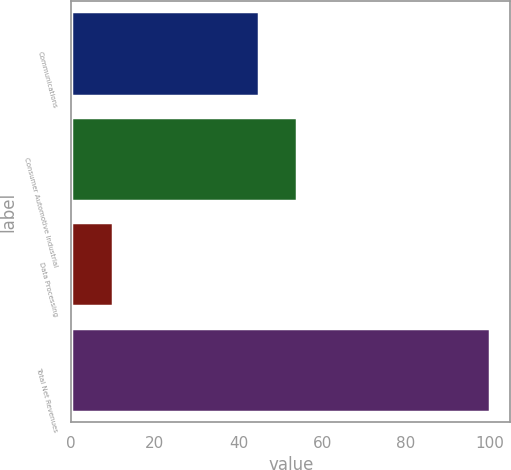Convert chart. <chart><loc_0><loc_0><loc_500><loc_500><bar_chart><fcel>Communications<fcel>Consumer Automotive Industrial<fcel>Data Processing<fcel>Total Net Revenues<nl><fcel>45<fcel>54<fcel>10<fcel>100<nl></chart> 